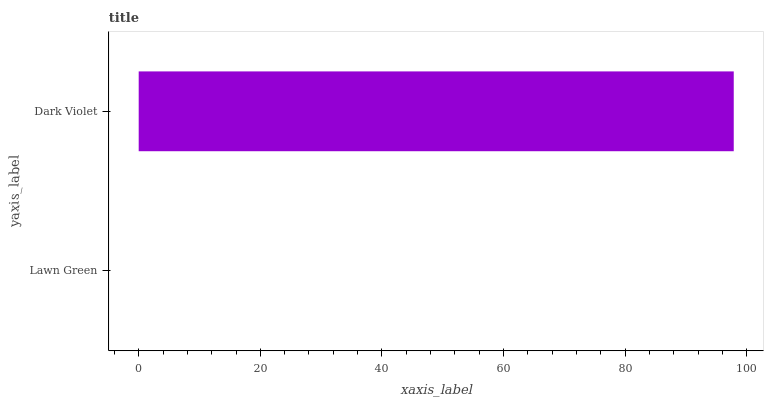Is Lawn Green the minimum?
Answer yes or no. Yes. Is Dark Violet the maximum?
Answer yes or no. Yes. Is Dark Violet the minimum?
Answer yes or no. No. Is Dark Violet greater than Lawn Green?
Answer yes or no. Yes. Is Lawn Green less than Dark Violet?
Answer yes or no. Yes. Is Lawn Green greater than Dark Violet?
Answer yes or no. No. Is Dark Violet less than Lawn Green?
Answer yes or no. No. Is Dark Violet the high median?
Answer yes or no. Yes. Is Lawn Green the low median?
Answer yes or no. Yes. Is Lawn Green the high median?
Answer yes or no. No. Is Dark Violet the low median?
Answer yes or no. No. 